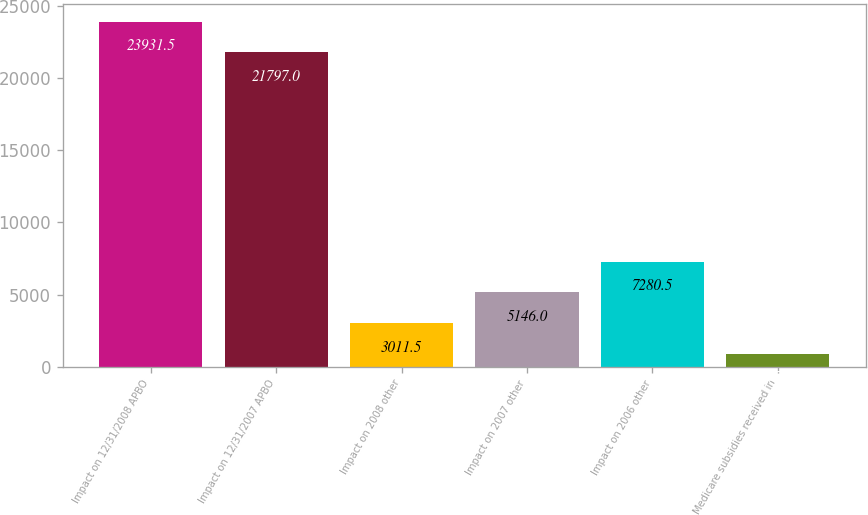<chart> <loc_0><loc_0><loc_500><loc_500><bar_chart><fcel>Impact on 12/31/2008 APBO<fcel>Impact on 12/31/2007 APBO<fcel>Impact on 2008 other<fcel>Impact on 2007 other<fcel>Impact on 2006 other<fcel>Medicare subsidies received in<nl><fcel>23931.5<fcel>21797<fcel>3011.5<fcel>5146<fcel>7280.5<fcel>877<nl></chart> 